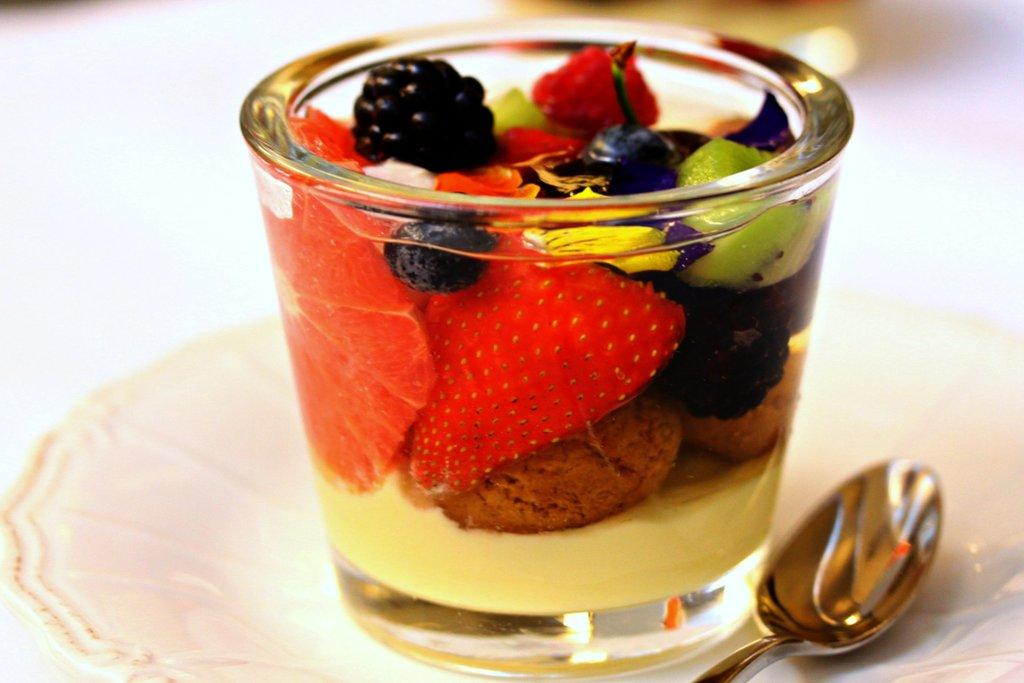What type of food is visible in the image? There are fruits and a food item in a glass in the image. What utensil is present in the image? There is a spoon in the image. What type of dish is visible in the image? There is a white plate in the image. Where is the store located in the image? There is no store present in the image. What type of nail can be seen in the image? There is no nail present in the image. 